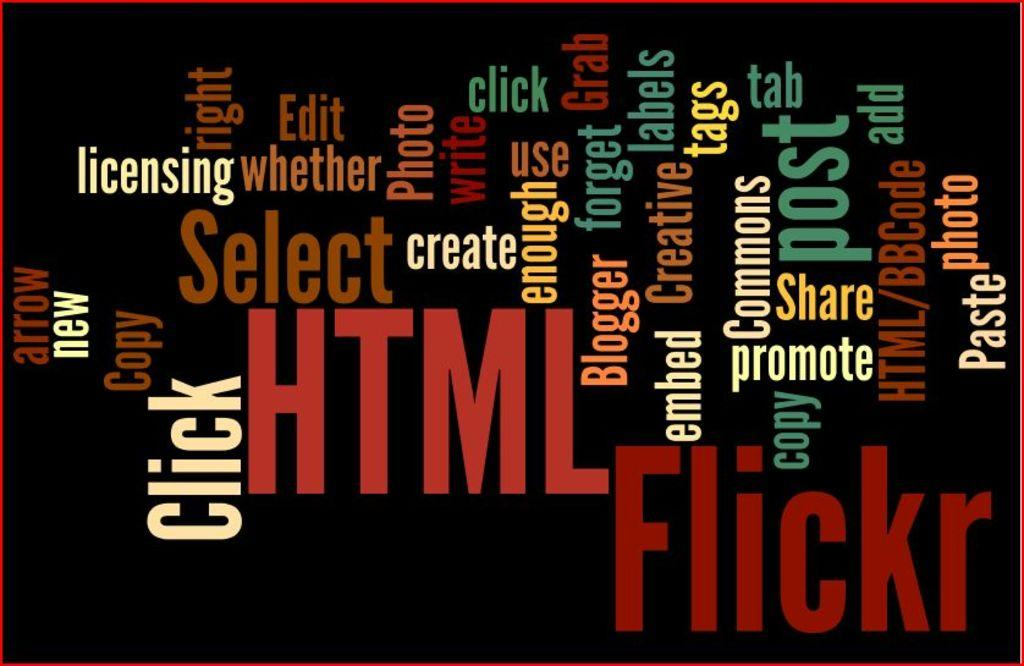<image>
Summarize the visual content of the image. A poster displaying various word associated with website and blogging. 